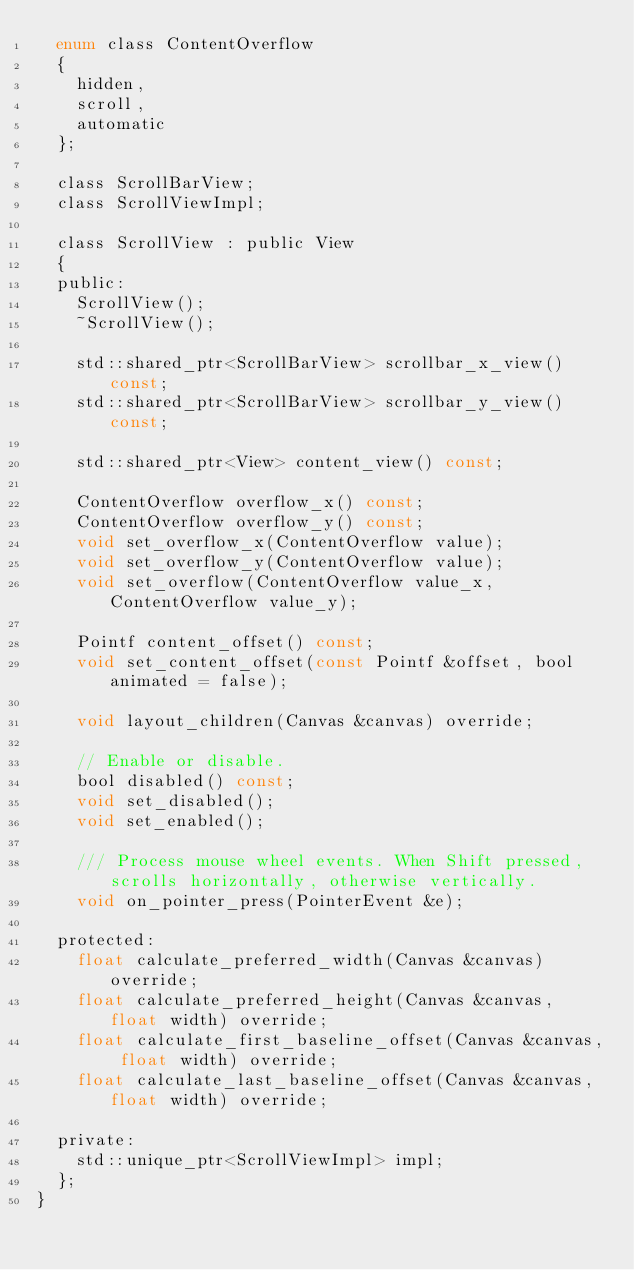<code> <loc_0><loc_0><loc_500><loc_500><_C_>	enum class ContentOverflow
	{
		hidden,
		scroll,
		automatic
	};
	
	class ScrollBarView;
	class ScrollViewImpl;
	
	class ScrollView : public View
	{
	public:
		ScrollView();
		~ScrollView();
		
		std::shared_ptr<ScrollBarView> scrollbar_x_view() const;
		std::shared_ptr<ScrollBarView> scrollbar_y_view() const;
		
		std::shared_ptr<View> content_view() const;
		
		ContentOverflow overflow_x() const;
		ContentOverflow overflow_y() const;
		void set_overflow_x(ContentOverflow value);
		void set_overflow_y(ContentOverflow value);
		void set_overflow(ContentOverflow value_x, ContentOverflow value_y);
		
		Pointf content_offset() const;
		void set_content_offset(const Pointf &offset, bool animated = false);
		
		void layout_children(Canvas &canvas) override;

		// Enable or disable.
		bool disabled() const;
		void set_disabled();
		void set_enabled();

		/// Process mouse wheel events. When Shift pressed, scrolls horizontally, otherwise vertically.
		void on_pointer_press(PointerEvent &e);

	protected:
		float calculate_preferred_width(Canvas &canvas) override;
		float calculate_preferred_height(Canvas &canvas, float width) override;
		float calculate_first_baseline_offset(Canvas &canvas, float width) override;
		float calculate_last_baseline_offset(Canvas &canvas, float width) override;
		
	private:
		std::unique_ptr<ScrollViewImpl> impl;
	};
}
</code> 